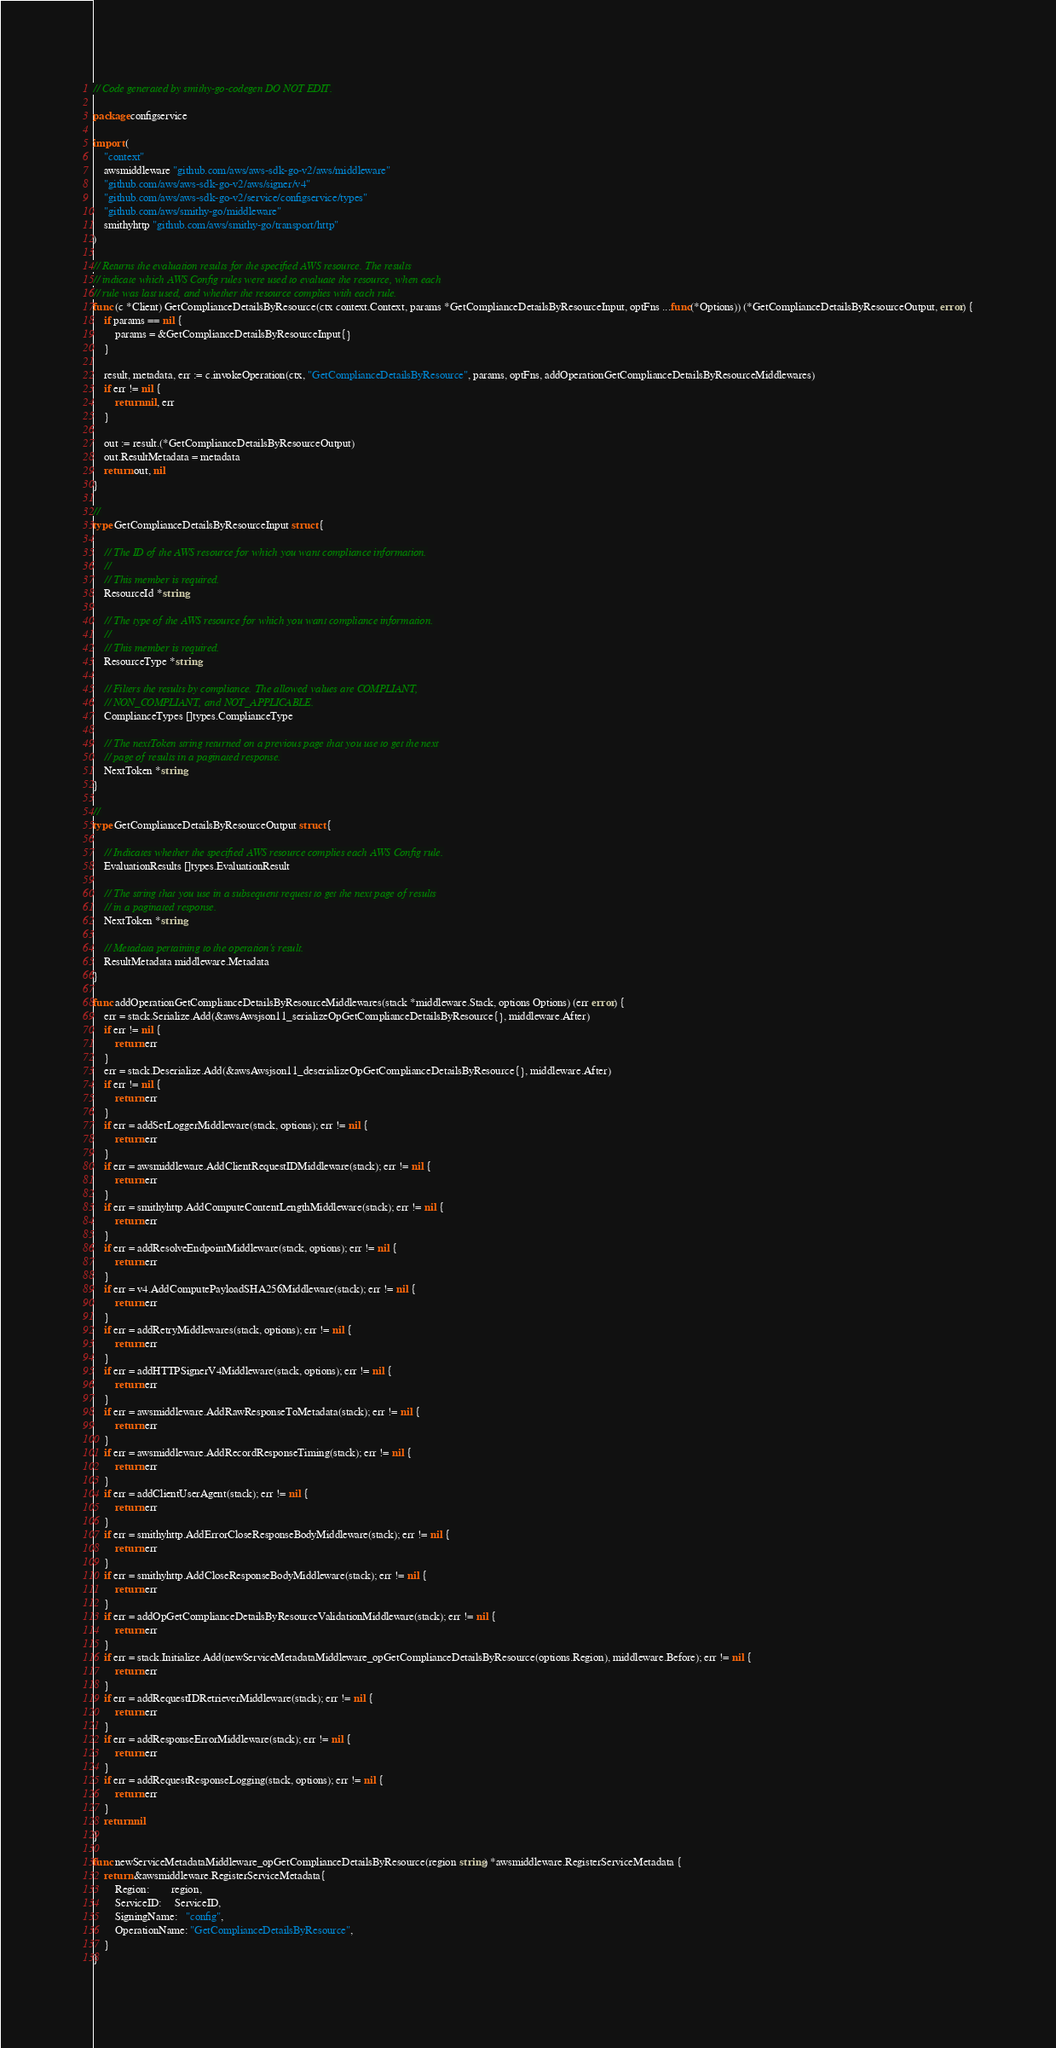Convert code to text. <code><loc_0><loc_0><loc_500><loc_500><_Go_>// Code generated by smithy-go-codegen DO NOT EDIT.

package configservice

import (
	"context"
	awsmiddleware "github.com/aws/aws-sdk-go-v2/aws/middleware"
	"github.com/aws/aws-sdk-go-v2/aws/signer/v4"
	"github.com/aws/aws-sdk-go-v2/service/configservice/types"
	"github.com/aws/smithy-go/middleware"
	smithyhttp "github.com/aws/smithy-go/transport/http"
)

// Returns the evaluation results for the specified AWS resource. The results
// indicate which AWS Config rules were used to evaluate the resource, when each
// rule was last used, and whether the resource complies with each rule.
func (c *Client) GetComplianceDetailsByResource(ctx context.Context, params *GetComplianceDetailsByResourceInput, optFns ...func(*Options)) (*GetComplianceDetailsByResourceOutput, error) {
	if params == nil {
		params = &GetComplianceDetailsByResourceInput{}
	}

	result, metadata, err := c.invokeOperation(ctx, "GetComplianceDetailsByResource", params, optFns, addOperationGetComplianceDetailsByResourceMiddlewares)
	if err != nil {
		return nil, err
	}

	out := result.(*GetComplianceDetailsByResourceOutput)
	out.ResultMetadata = metadata
	return out, nil
}

//
type GetComplianceDetailsByResourceInput struct {

	// The ID of the AWS resource for which you want compliance information.
	//
	// This member is required.
	ResourceId *string

	// The type of the AWS resource for which you want compliance information.
	//
	// This member is required.
	ResourceType *string

	// Filters the results by compliance. The allowed values are COMPLIANT,
	// NON_COMPLIANT, and NOT_APPLICABLE.
	ComplianceTypes []types.ComplianceType

	// The nextToken string returned on a previous page that you use to get the next
	// page of results in a paginated response.
	NextToken *string
}

//
type GetComplianceDetailsByResourceOutput struct {

	// Indicates whether the specified AWS resource complies each AWS Config rule.
	EvaluationResults []types.EvaluationResult

	// The string that you use in a subsequent request to get the next page of results
	// in a paginated response.
	NextToken *string

	// Metadata pertaining to the operation's result.
	ResultMetadata middleware.Metadata
}

func addOperationGetComplianceDetailsByResourceMiddlewares(stack *middleware.Stack, options Options) (err error) {
	err = stack.Serialize.Add(&awsAwsjson11_serializeOpGetComplianceDetailsByResource{}, middleware.After)
	if err != nil {
		return err
	}
	err = stack.Deserialize.Add(&awsAwsjson11_deserializeOpGetComplianceDetailsByResource{}, middleware.After)
	if err != nil {
		return err
	}
	if err = addSetLoggerMiddleware(stack, options); err != nil {
		return err
	}
	if err = awsmiddleware.AddClientRequestIDMiddleware(stack); err != nil {
		return err
	}
	if err = smithyhttp.AddComputeContentLengthMiddleware(stack); err != nil {
		return err
	}
	if err = addResolveEndpointMiddleware(stack, options); err != nil {
		return err
	}
	if err = v4.AddComputePayloadSHA256Middleware(stack); err != nil {
		return err
	}
	if err = addRetryMiddlewares(stack, options); err != nil {
		return err
	}
	if err = addHTTPSignerV4Middleware(stack, options); err != nil {
		return err
	}
	if err = awsmiddleware.AddRawResponseToMetadata(stack); err != nil {
		return err
	}
	if err = awsmiddleware.AddRecordResponseTiming(stack); err != nil {
		return err
	}
	if err = addClientUserAgent(stack); err != nil {
		return err
	}
	if err = smithyhttp.AddErrorCloseResponseBodyMiddleware(stack); err != nil {
		return err
	}
	if err = smithyhttp.AddCloseResponseBodyMiddleware(stack); err != nil {
		return err
	}
	if err = addOpGetComplianceDetailsByResourceValidationMiddleware(stack); err != nil {
		return err
	}
	if err = stack.Initialize.Add(newServiceMetadataMiddleware_opGetComplianceDetailsByResource(options.Region), middleware.Before); err != nil {
		return err
	}
	if err = addRequestIDRetrieverMiddleware(stack); err != nil {
		return err
	}
	if err = addResponseErrorMiddleware(stack); err != nil {
		return err
	}
	if err = addRequestResponseLogging(stack, options); err != nil {
		return err
	}
	return nil
}

func newServiceMetadataMiddleware_opGetComplianceDetailsByResource(region string) *awsmiddleware.RegisterServiceMetadata {
	return &awsmiddleware.RegisterServiceMetadata{
		Region:        region,
		ServiceID:     ServiceID,
		SigningName:   "config",
		OperationName: "GetComplianceDetailsByResource",
	}
}
</code> 